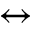Convert formula to latex. <formula><loc_0><loc_0><loc_500><loc_500>\leftrightarrow</formula> 